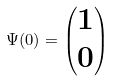<formula> <loc_0><loc_0><loc_500><loc_500>\Psi ( 0 ) = \begin{pmatrix} 1 \\ 0 \end{pmatrix}</formula> 